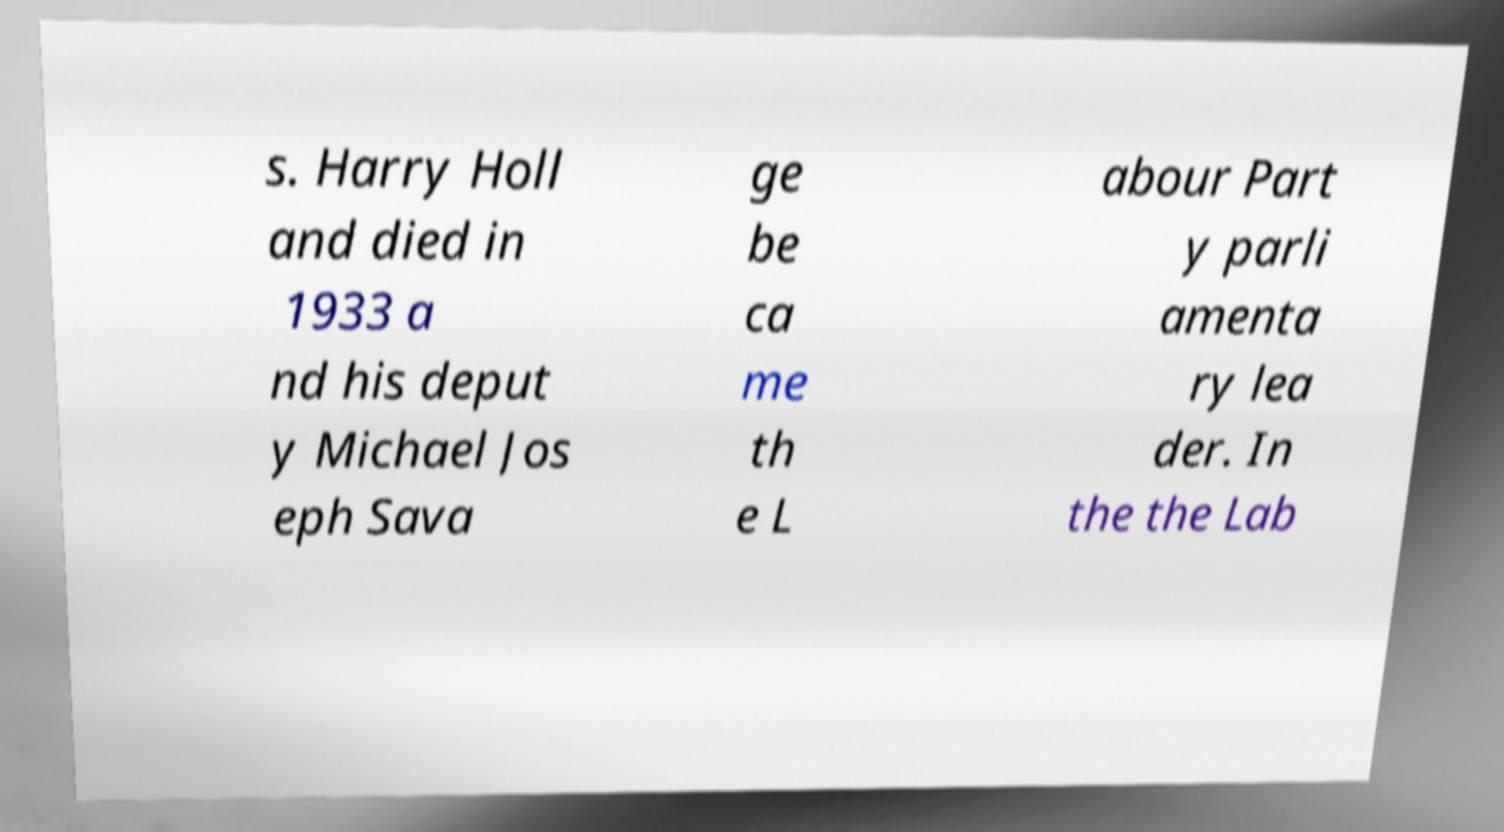Could you assist in decoding the text presented in this image and type it out clearly? s. Harry Holl and died in 1933 a nd his deput y Michael Jos eph Sava ge be ca me th e L abour Part y parli amenta ry lea der. In the the Lab 